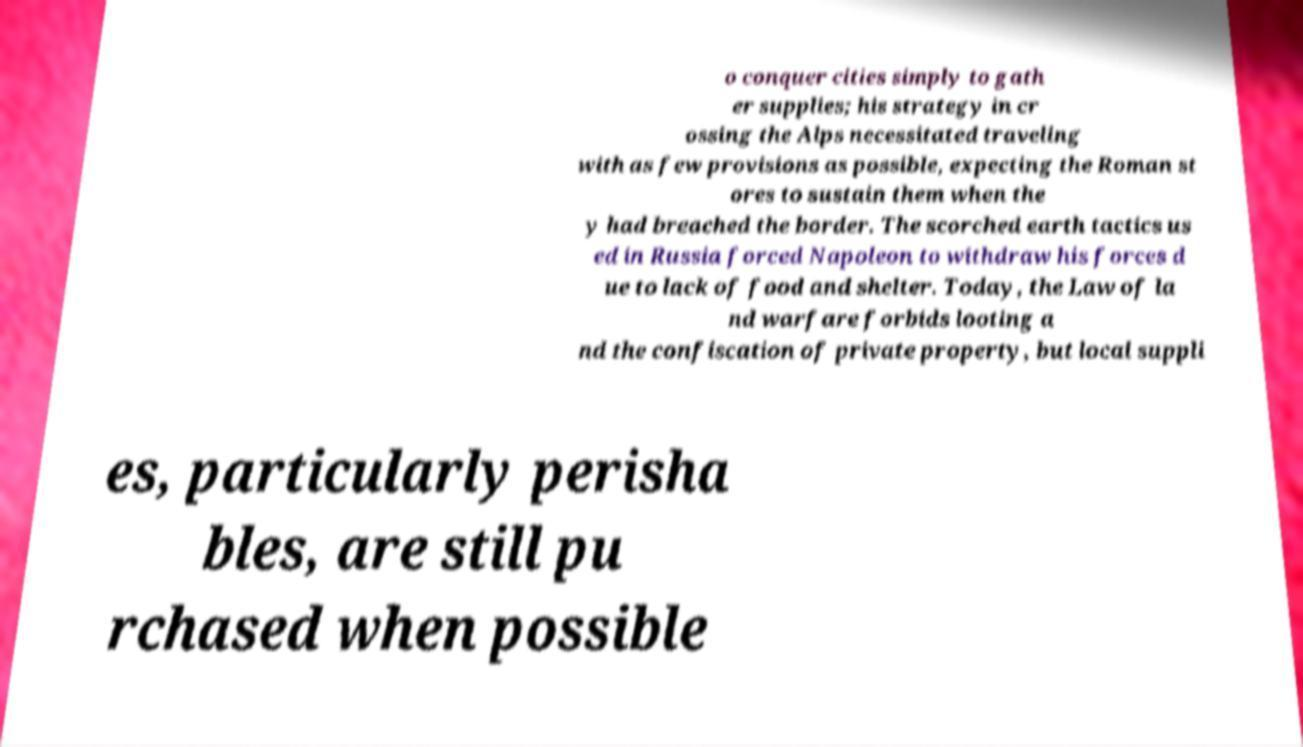Can you read and provide the text displayed in the image?This photo seems to have some interesting text. Can you extract and type it out for me? o conquer cities simply to gath er supplies; his strategy in cr ossing the Alps necessitated traveling with as few provisions as possible, expecting the Roman st ores to sustain them when the y had breached the border. The scorched earth tactics us ed in Russia forced Napoleon to withdraw his forces d ue to lack of food and shelter. Today, the Law of la nd warfare forbids looting a nd the confiscation of private property, but local suppli es, particularly perisha bles, are still pu rchased when possible 